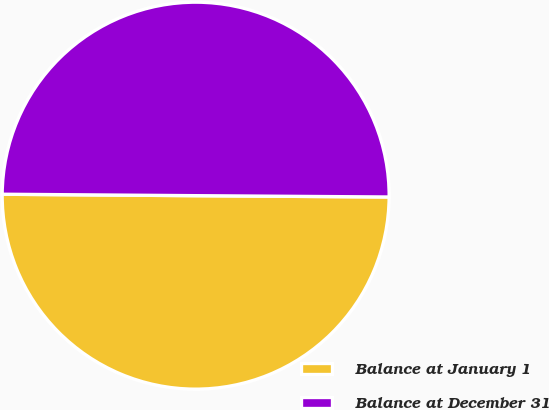<chart> <loc_0><loc_0><loc_500><loc_500><pie_chart><fcel>Balance at January 1<fcel>Balance at December 31<nl><fcel>50.01%<fcel>49.99%<nl></chart> 